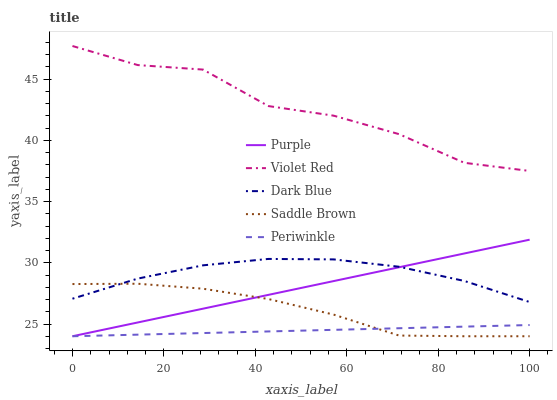Does Periwinkle have the minimum area under the curve?
Answer yes or no. Yes. Does Violet Red have the maximum area under the curve?
Answer yes or no. Yes. Does Dark Blue have the minimum area under the curve?
Answer yes or no. No. Does Dark Blue have the maximum area under the curve?
Answer yes or no. No. Is Purple the smoothest?
Answer yes or no. Yes. Is Violet Red the roughest?
Answer yes or no. Yes. Is Dark Blue the smoothest?
Answer yes or no. No. Is Dark Blue the roughest?
Answer yes or no. No. Does Purple have the lowest value?
Answer yes or no. Yes. Does Dark Blue have the lowest value?
Answer yes or no. No. Does Violet Red have the highest value?
Answer yes or no. Yes. Does Dark Blue have the highest value?
Answer yes or no. No. Is Dark Blue less than Violet Red?
Answer yes or no. Yes. Is Dark Blue greater than Periwinkle?
Answer yes or no. Yes. Does Purple intersect Saddle Brown?
Answer yes or no. Yes. Is Purple less than Saddle Brown?
Answer yes or no. No. Is Purple greater than Saddle Brown?
Answer yes or no. No. Does Dark Blue intersect Violet Red?
Answer yes or no. No. 